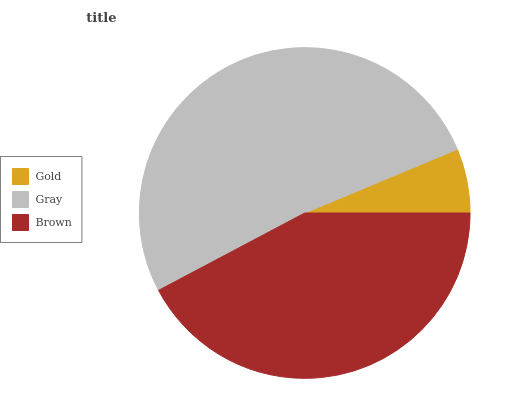Is Gold the minimum?
Answer yes or no. Yes. Is Gray the maximum?
Answer yes or no. Yes. Is Brown the minimum?
Answer yes or no. No. Is Brown the maximum?
Answer yes or no. No. Is Gray greater than Brown?
Answer yes or no. Yes. Is Brown less than Gray?
Answer yes or no. Yes. Is Brown greater than Gray?
Answer yes or no. No. Is Gray less than Brown?
Answer yes or no. No. Is Brown the high median?
Answer yes or no. Yes. Is Brown the low median?
Answer yes or no. Yes. Is Gold the high median?
Answer yes or no. No. Is Gold the low median?
Answer yes or no. No. 